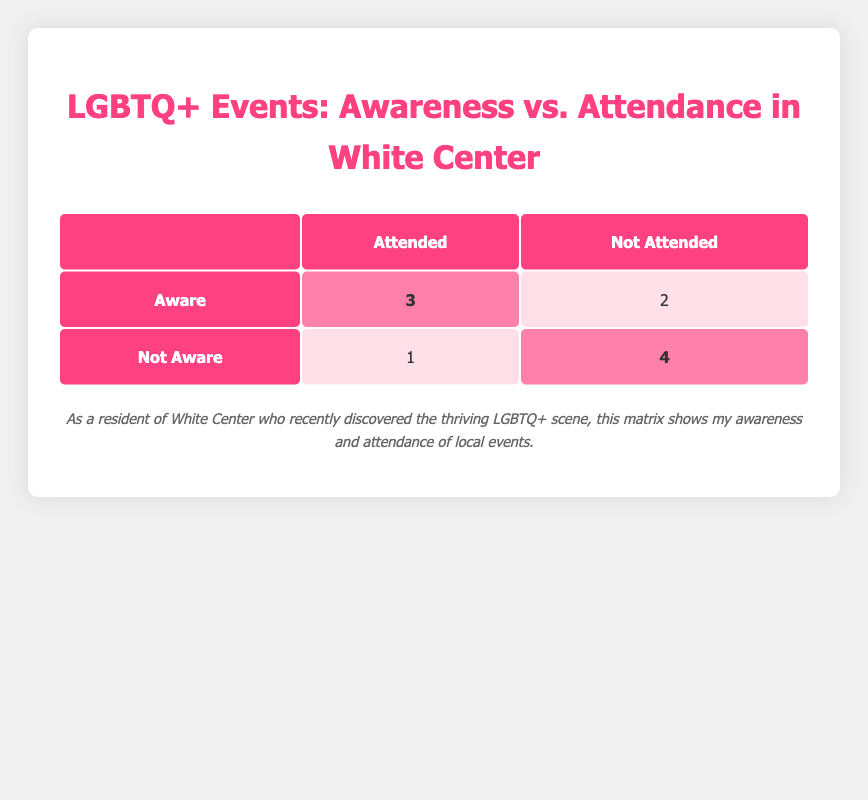What is the total number of attendees who were aware of LGBTQ+ events? Look at the "Aware" row in the "Attended" column. There are 3 attendees who were aware and attended the events.
Answer: 3 How many people in total did not attend LGBTQ+ events? To find the total, look at the "Not Attended" column. Adding the values: 2 (Aware) + 4 (Not Aware) = 6.
Answer: 6 Is it true that more people were aware of the LGBTQ+ events than not aware? Yes, the "Aware" group has a total of 5 (3 attended + 2 not attended), while the "Not Aware" group has a total of 5 (1 attended + 4 not attended). They are equal, so the statement is false.
Answer: No What is the ratio of attendees who were aware to those who were not aware? The number of attendees who were aware is 3, and those who were not aware is 1. The ratio is 3:1.
Answer: 3:1 What percentage of individuals who were aware attended the events? There are 3 attendees who were aware. To find the percentage of attendees among the aware group: (3 attended / 5 total aware) * 100 = 60%.
Answer: 60% How many more individuals attended the events than those who were not aware and did not attend? Those who attended: 4 (Aware:3 + Not Aware:1). Those who did not attend: 4 (Not Aware). The difference is 4 - 4 = 0.
Answer: 0 